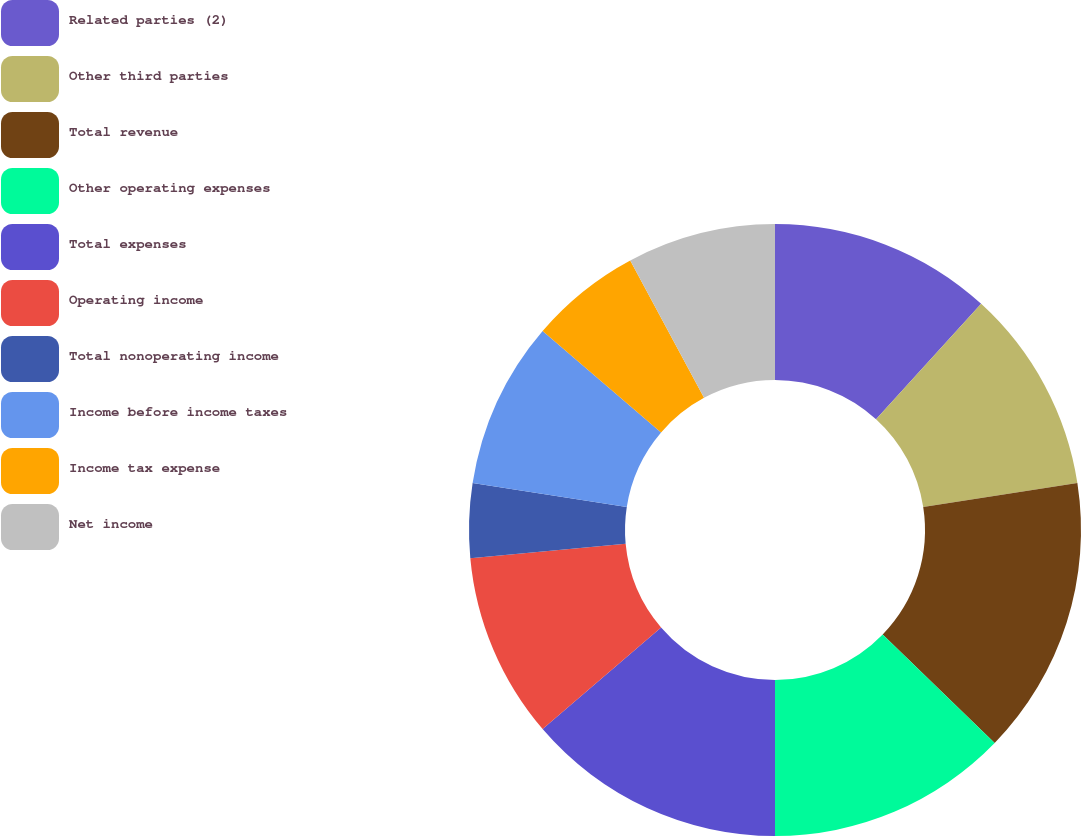Convert chart to OTSL. <chart><loc_0><loc_0><loc_500><loc_500><pie_chart><fcel>Related parties (2)<fcel>Other third parties<fcel>Total revenue<fcel>Other operating expenses<fcel>Total expenses<fcel>Operating income<fcel>Total nonoperating income<fcel>Income before income taxes<fcel>Income tax expense<fcel>Net income<nl><fcel>11.76%<fcel>10.78%<fcel>14.7%<fcel>12.74%<fcel>13.72%<fcel>9.8%<fcel>3.92%<fcel>8.82%<fcel>5.88%<fcel>7.84%<nl></chart> 